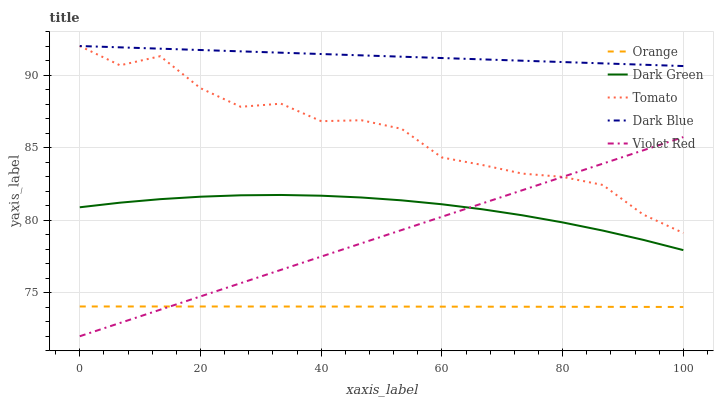Does Orange have the minimum area under the curve?
Answer yes or no. Yes. Does Dark Blue have the maximum area under the curve?
Answer yes or no. Yes. Does Tomato have the minimum area under the curve?
Answer yes or no. No. Does Tomato have the maximum area under the curve?
Answer yes or no. No. Is Violet Red the smoothest?
Answer yes or no. Yes. Is Tomato the roughest?
Answer yes or no. Yes. Is Tomato the smoothest?
Answer yes or no. No. Is Violet Red the roughest?
Answer yes or no. No. Does Violet Red have the lowest value?
Answer yes or no. Yes. Does Tomato have the lowest value?
Answer yes or no. No. Does Dark Blue have the highest value?
Answer yes or no. Yes. Does Violet Red have the highest value?
Answer yes or no. No. Is Orange less than Dark Green?
Answer yes or no. Yes. Is Tomato greater than Dark Green?
Answer yes or no. Yes. Does Violet Red intersect Dark Green?
Answer yes or no. Yes. Is Violet Red less than Dark Green?
Answer yes or no. No. Is Violet Red greater than Dark Green?
Answer yes or no. No. Does Orange intersect Dark Green?
Answer yes or no. No. 